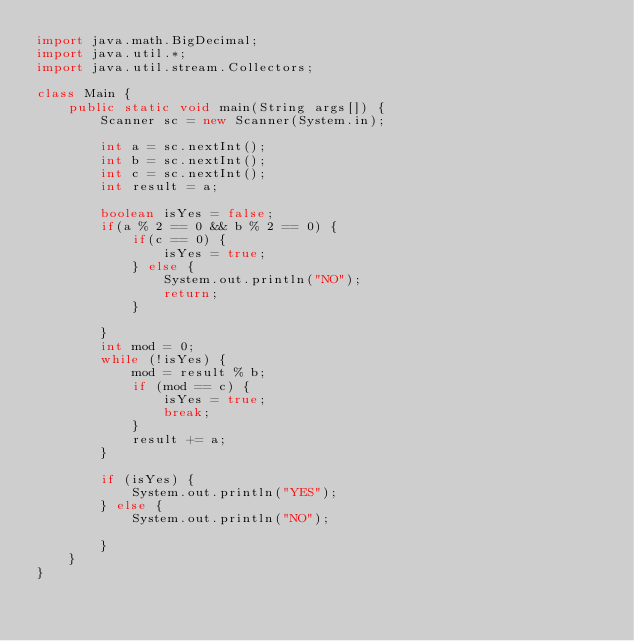Convert code to text. <code><loc_0><loc_0><loc_500><loc_500><_Java_>import java.math.BigDecimal;
import java.util.*;
import java.util.stream.Collectors;

class Main {
    public static void main(String args[]) {
        Scanner sc = new Scanner(System.in);
      
        int a = sc.nextInt();
        int b = sc.nextInt();
        int c = sc.nextInt();
        int result = a;

        boolean isYes = false;
        if(a % 2 == 0 && b % 2 == 0) {
            if(c == 0) {
                isYes = true;
            } else {
                System.out.println("NO");
                return;
            }

        }
        int mod = 0;
        while (!isYes) {
            mod = result % b;
            if (mod == c) {
                isYes = true;
                break;
            }
            result += a;
        }

        if (isYes) {
            System.out.println("YES");
        } else {
            System.out.println("NO");

        }
    }
}</code> 